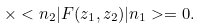Convert formula to latex. <formula><loc_0><loc_0><loc_500><loc_500>\times < n _ { 2 } | F ( z _ { 1 } , z _ { 2 } ) | n _ { 1 } > = 0 .</formula> 